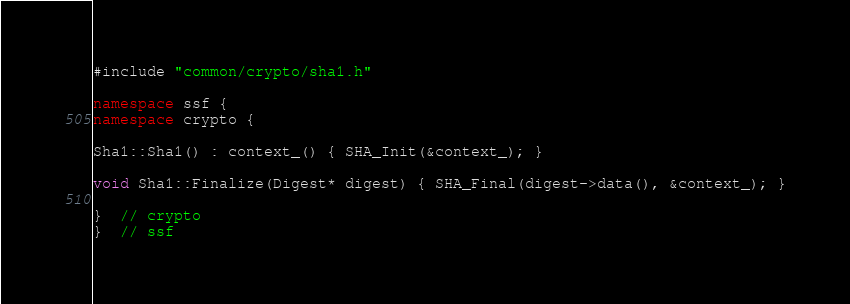Convert code to text. <code><loc_0><loc_0><loc_500><loc_500><_C++_>#include "common/crypto/sha1.h"

namespace ssf {
namespace crypto {

Sha1::Sha1() : context_() { SHA_Init(&context_); }

void Sha1::Finalize(Digest* digest) { SHA_Final(digest->data(), &context_); }

}  // crypto
}  // ssf</code> 